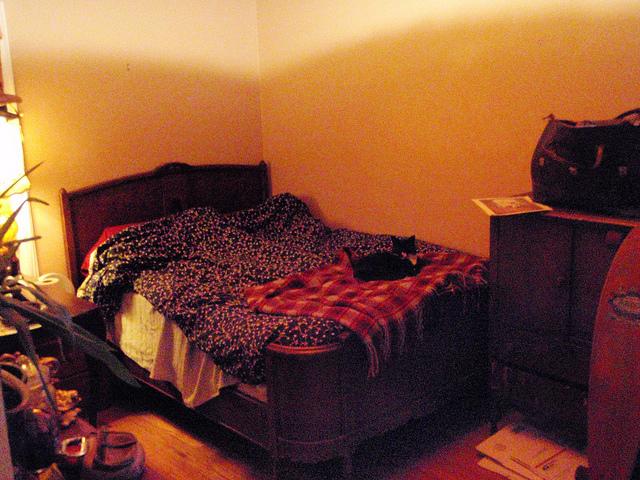Can two people sleep in this bed?
Concise answer only. Yes. What animal is laying on the bed?
Keep it brief. Cat. Is the bed done?
Give a very brief answer. No. 